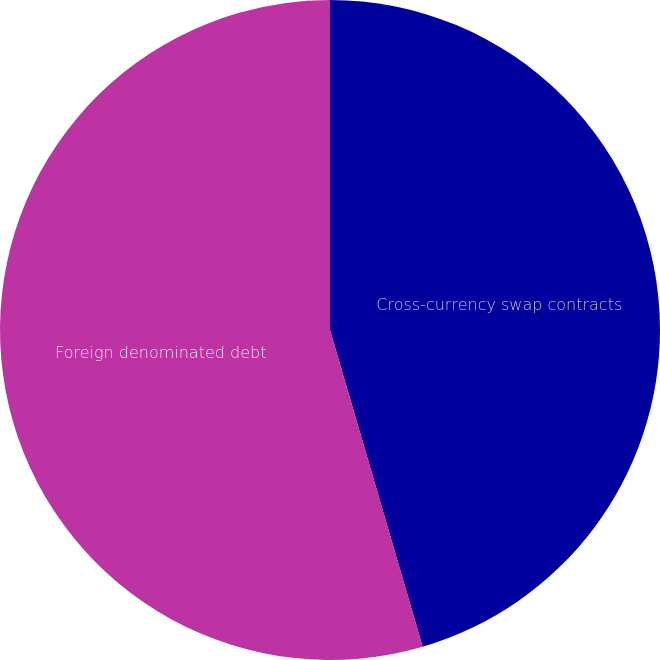<chart> <loc_0><loc_0><loc_500><loc_500><pie_chart><fcel>Cross-currency swap contracts<fcel>Foreign denominated debt<nl><fcel>45.47%<fcel>54.53%<nl></chart> 